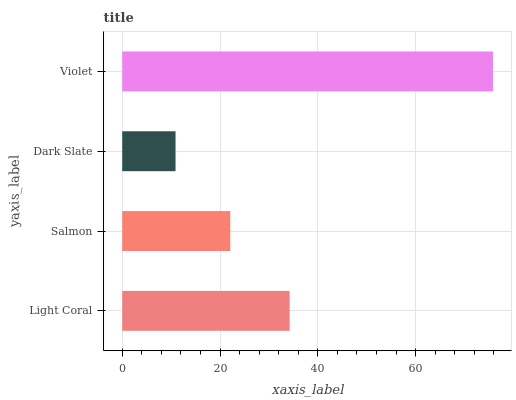Is Dark Slate the minimum?
Answer yes or no. Yes. Is Violet the maximum?
Answer yes or no. Yes. Is Salmon the minimum?
Answer yes or no. No. Is Salmon the maximum?
Answer yes or no. No. Is Light Coral greater than Salmon?
Answer yes or no. Yes. Is Salmon less than Light Coral?
Answer yes or no. Yes. Is Salmon greater than Light Coral?
Answer yes or no. No. Is Light Coral less than Salmon?
Answer yes or no. No. Is Light Coral the high median?
Answer yes or no. Yes. Is Salmon the low median?
Answer yes or no. Yes. Is Salmon the high median?
Answer yes or no. No. Is Dark Slate the low median?
Answer yes or no. No. 